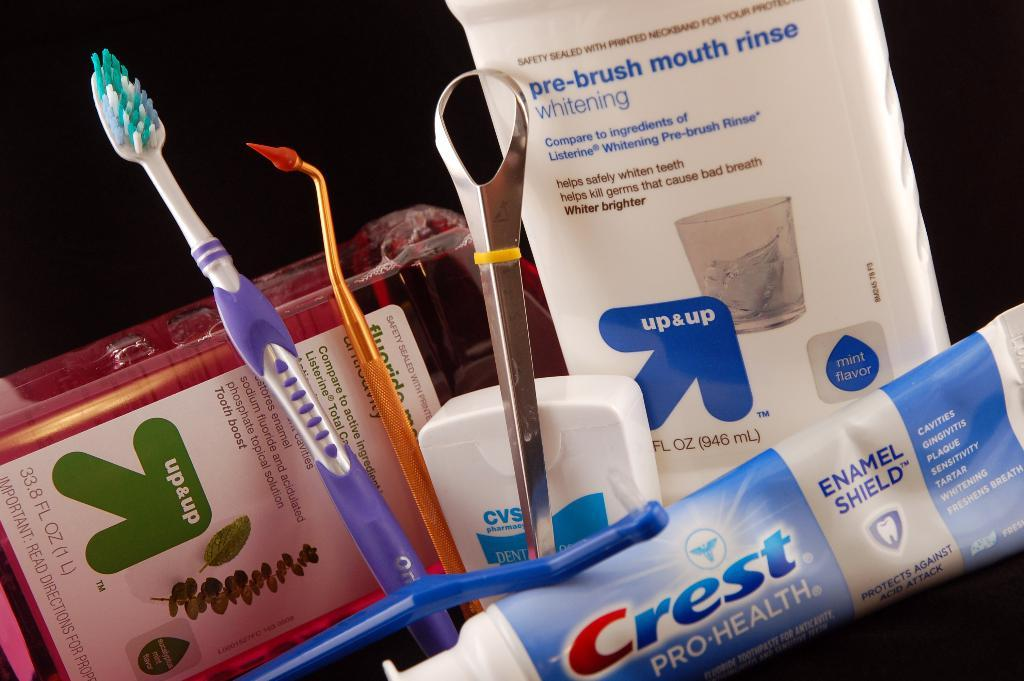<image>
Create a compact narrative representing the image presented. Various tooth cleaning products sit together, including Crest toothpaste and CVS floss. 